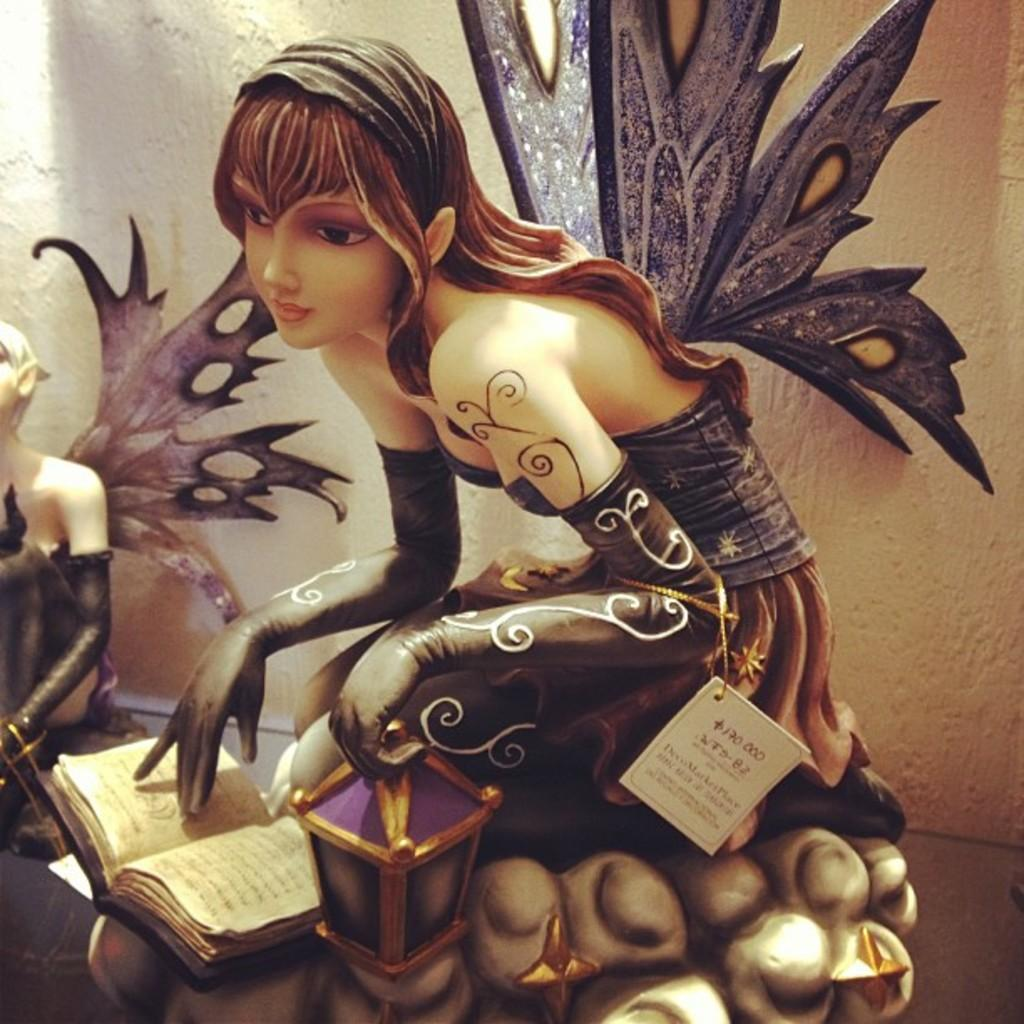What type of art is present in the image? There are sculptures in the image. Where are the sculptures located? The sculptures are on a surface. What can be seen in the background of the image? There is a wall in the background of the image. Where is the nest located in the image? There is no nest present in the image. Can you describe the coat that is hanging on the wall in the image? There is no coat present in the image; only sculptures and a wall are visible. 